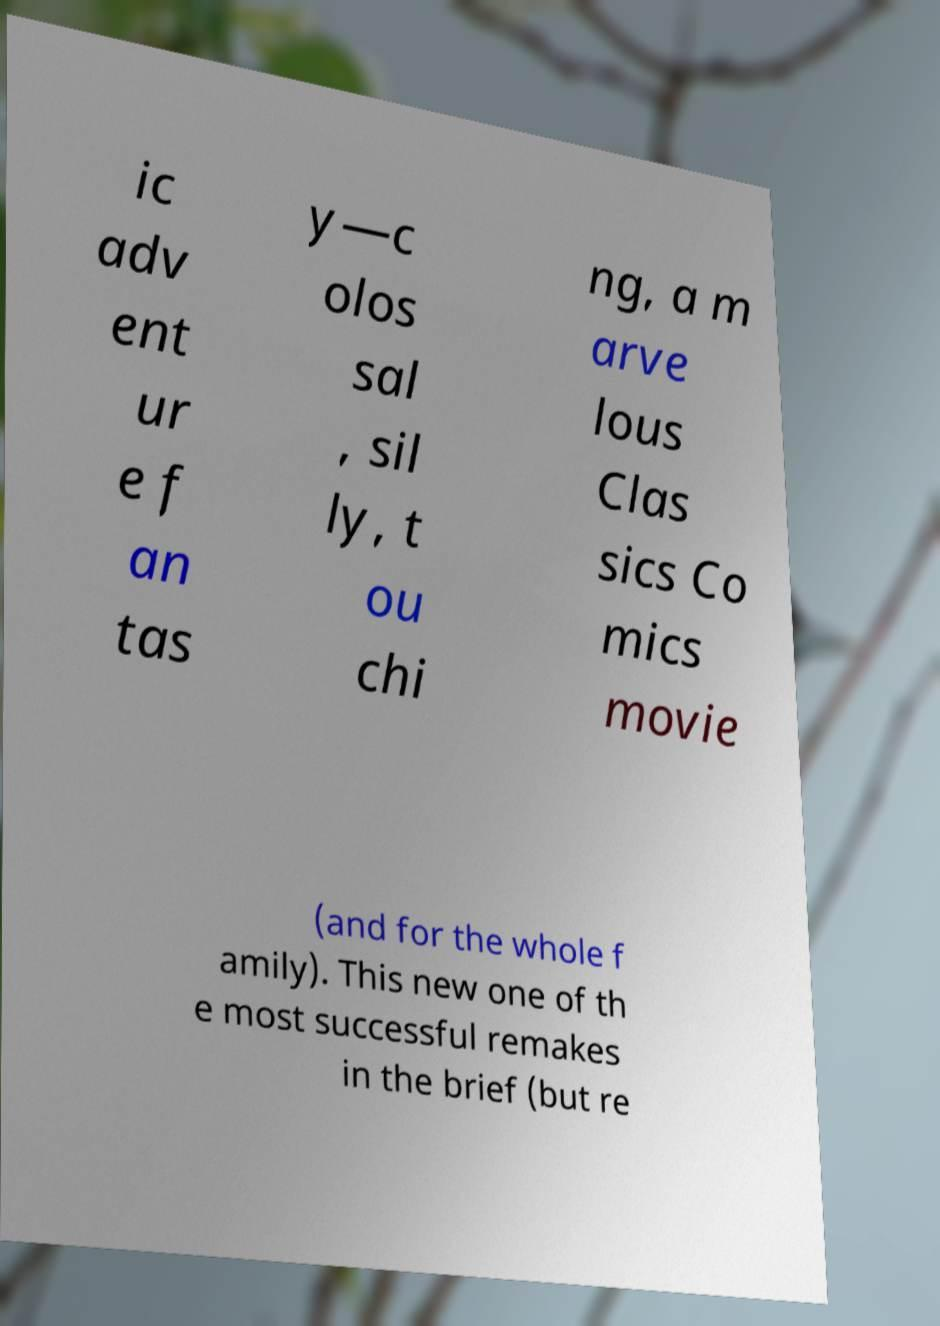Can you read and provide the text displayed in the image?This photo seems to have some interesting text. Can you extract and type it out for me? ic adv ent ur e f an tas y—c olos sal , sil ly, t ou chi ng, a m arve lous Clas sics Co mics movie (and for the whole f amily). This new one of th e most successful remakes in the brief (but re 